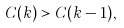Convert formula to latex. <formula><loc_0><loc_0><loc_500><loc_500>C ( k ) > C ( k - 1 ) ,</formula> 